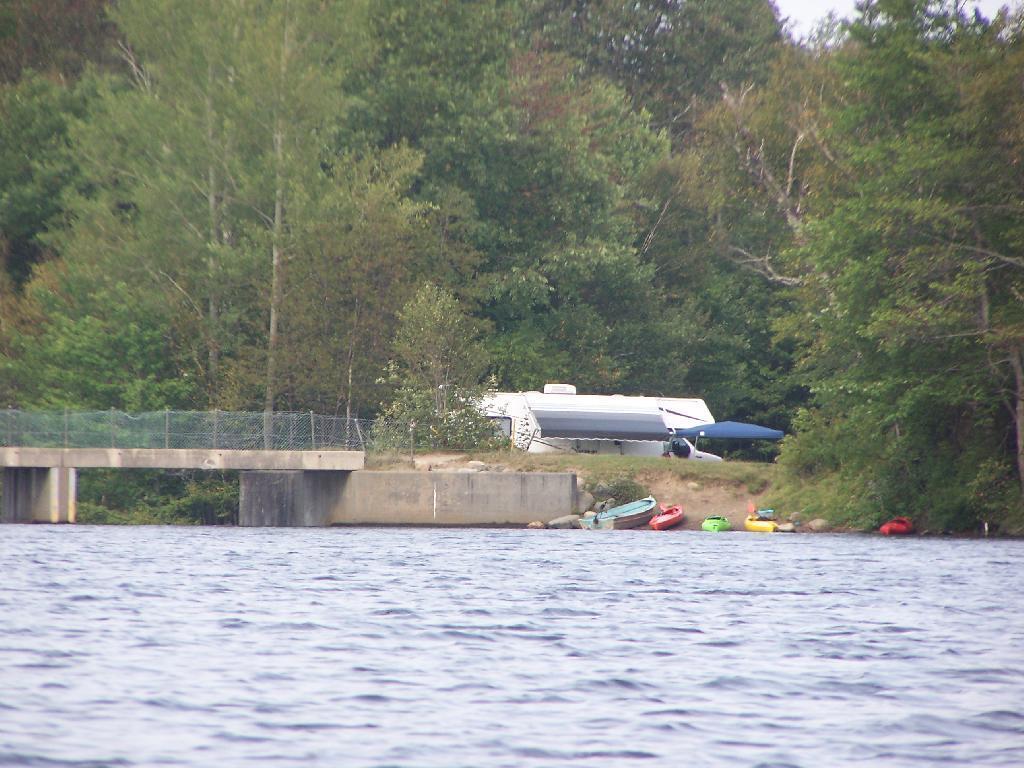Can you describe this image briefly? In this image we can see a river on which there is a bridge which has a fencing and also we can see some trees, vehicle and some boats. 